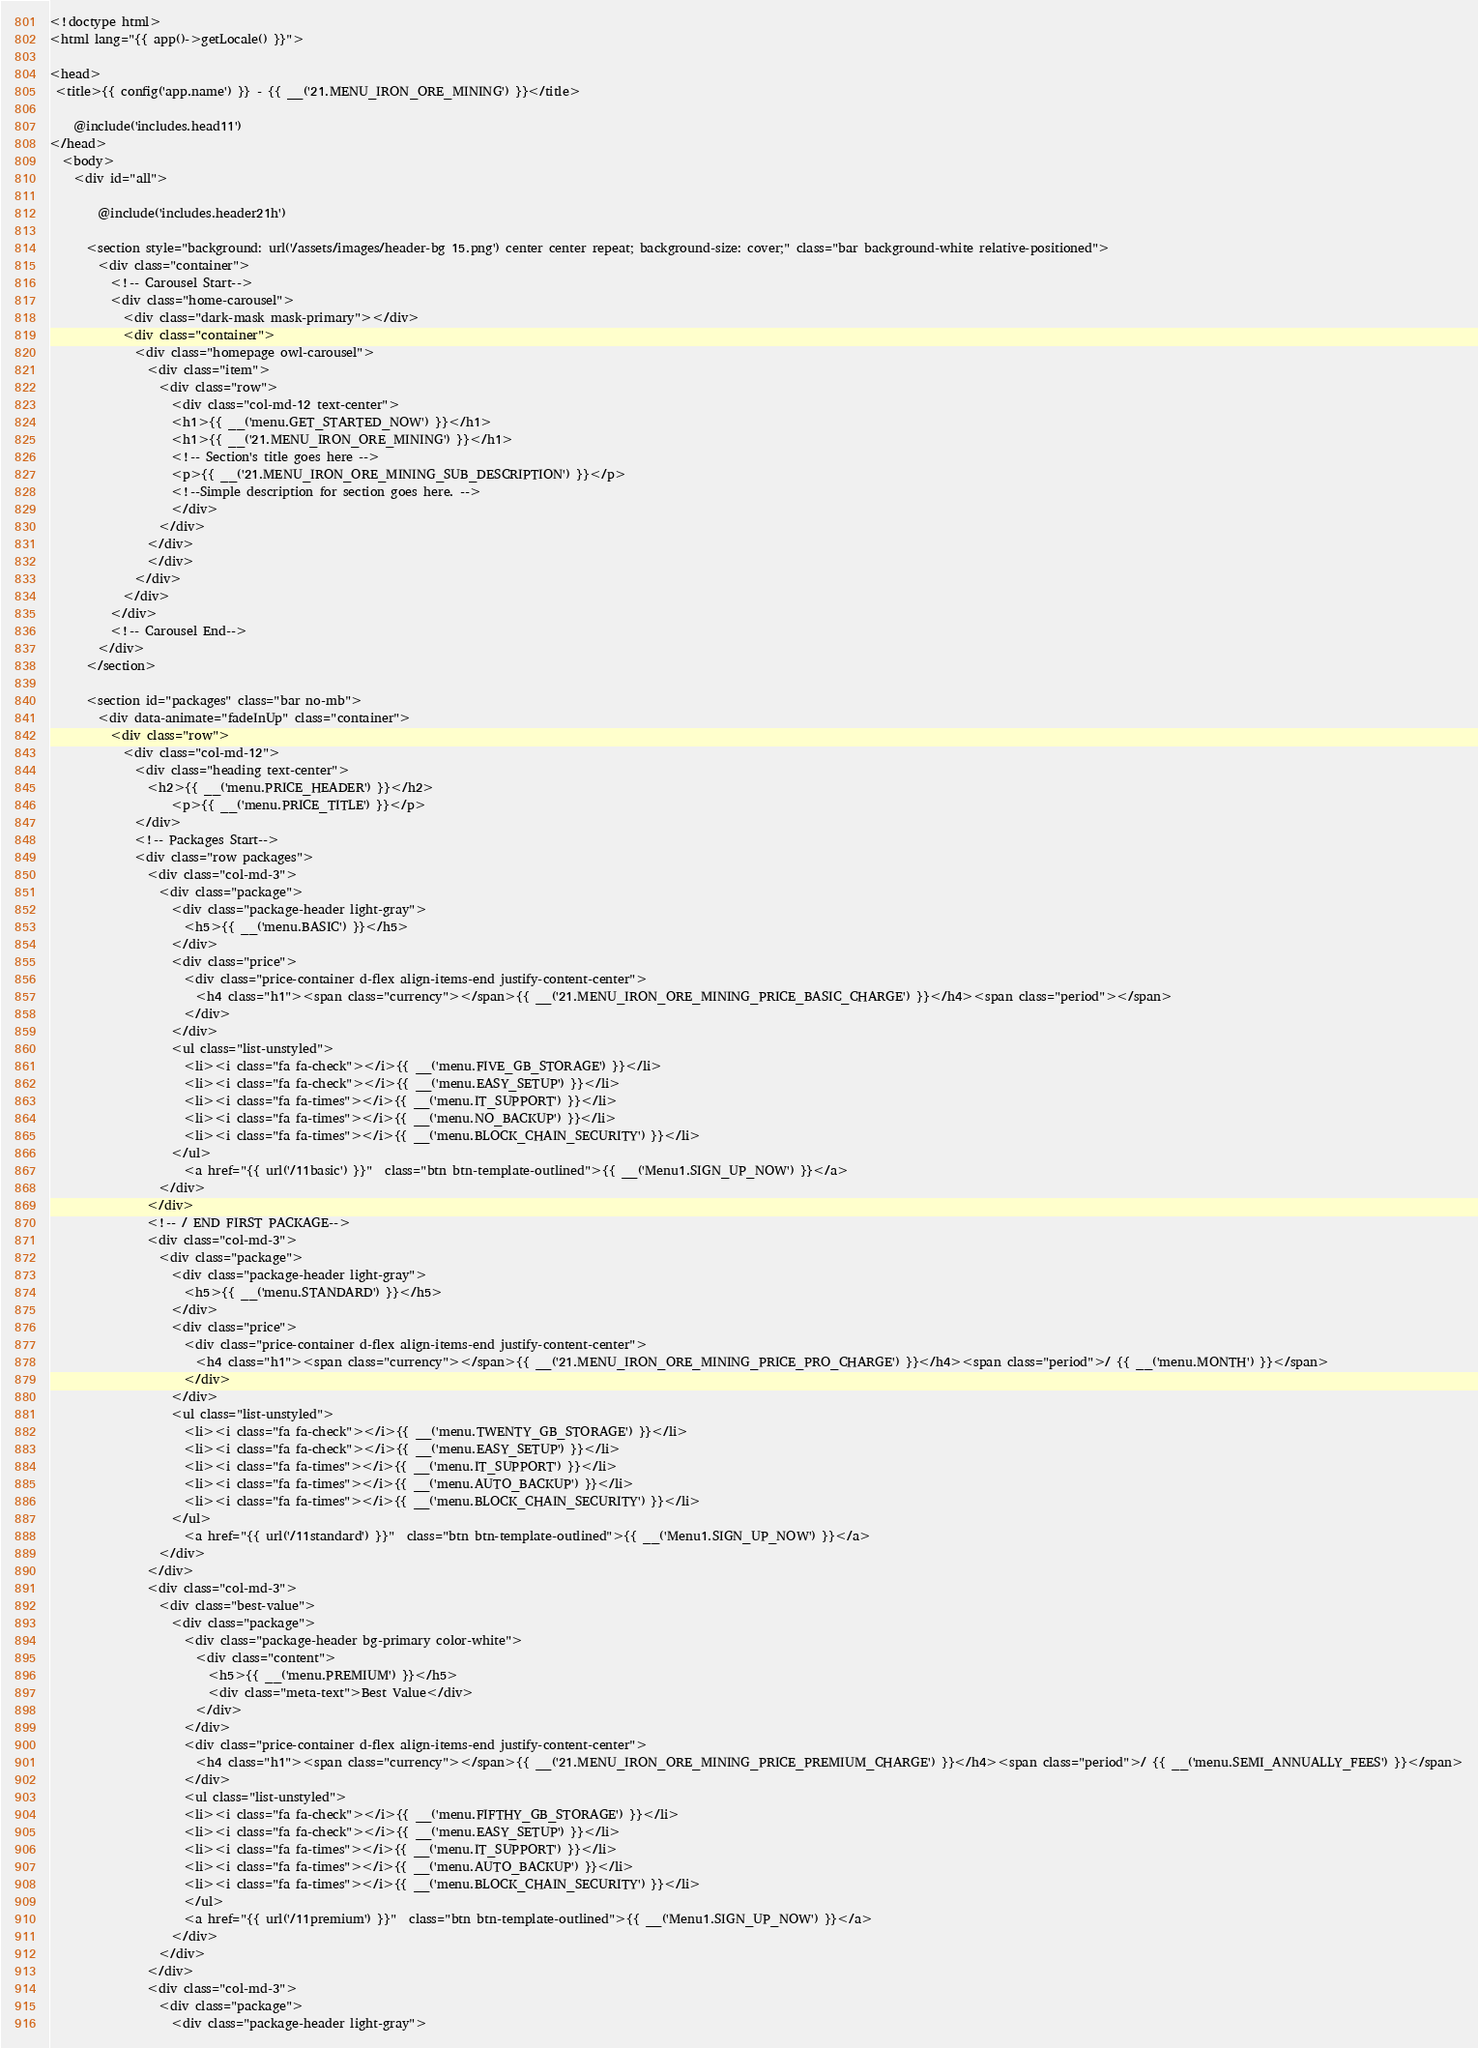Convert code to text. <code><loc_0><loc_0><loc_500><loc_500><_PHP_><!doctype html>
<html lang="{{ app()->getLocale() }}">
	  
<head>  
 <title>{{ config('app.name') }} - {{ __('21.MENU_IRON_ORE_MINING') }}</title>    
	
    @include('includes.head11')
</head>   
  <body>
    <div id="all">  
		
        @include('includes.header21h') 
      
      <section style="background: url('/assets/images/header-bg 15.png') center center repeat; background-size: cover;" class="bar background-white relative-positioned">
        <div class="container">
          <!-- Carousel Start-->
          <div class="home-carousel">
            <div class="dark-mask mask-primary"></div>
            <div class="container">
              <div class="homepage owl-carousel">
                <div class="item">
                  <div class="row">
                    <div class="col-md-12 text-center"> 
					<h1>{{ __('menu.GET_STARTED_NOW') }}</h1>
					<h1>{{ __('21.MENU_IRON_ORE_MINING') }}</h1>
					<!-- Section's title goes here -->
					<p>{{ __('21.MENU_IRON_ORE_MINING_SUB_DESCRIPTION') }}</p>
					<!--Simple description for section goes here. -->
                    </div> 
                  </div>
                </div>  
                </div>
              </div>
            </div>
          </div>
          <!-- Carousel End--> 
        </div>
      </section>
		
      <section id="packages" class="bar no-mb">
        <div data-animate="fadeInUp" class="container">
          <div class="row">
            <div class="col-md-12">
              <div class="heading text-center">
                <h2>{{ __('menu.PRICE_HEADER') }}</h2>
					<p>{{ __('menu.PRICE_TITLE') }}</p>
              </div> 
              <!-- Packages Start-->
              <div class="row packages">
                <div class="col-md-3">
                  <div class="package">
                    <div class="package-header light-gray">
                      <h5>{{ __('menu.BASIC') }}</h5>
                    </div>
                    <div class="price">
                      <div class="price-container d-flex align-items-end justify-content-center">
                        <h4 class="h1"><span class="currency"></span>{{ __('21.MENU_IRON_ORE_MINING_PRICE_BASIC_CHARGE') }}</h4><span class="period"></span>
                      </div>
                    </div>
                    <ul class="list-unstyled">
                      <li><i class="fa fa-check"></i>{{ __('menu.FIVE_GB_STORAGE') }}</li>
                      <li><i class="fa fa-check"></i>{{ __('menu.EASY_SETUP') }}</li>
                      <li><i class="fa fa-times"></i>{{ __('menu.IT_SUPPORT') }}</li>
                      <li><i class="fa fa-times"></i>{{ __('menu.NO_BACKUP') }}</li>
                      <li><i class="fa fa-times"></i>{{ __('menu.BLOCK_CHAIN_SECURITY') }}</li>
                    </ul>
					  <a href="{{ url('/11basic') }}"  class="btn btn-template-outlined">{{ __('Menu1.SIGN_UP_NOW') }}</a> 
                  </div>
                </div>
                <!-- / END FIRST PACKAGE-->
                <div class="col-md-3">
                  <div class="package">
                    <div class="package-header light-gray">
                      <h5>{{ __('menu.STANDARD') }}</h5>
                    </div>
                    <div class="price">
                      <div class="price-container d-flex align-items-end justify-content-center">
                        <h4 class="h1"><span class="currency"></span>{{ __('21.MENU_IRON_ORE_MINING_PRICE_PRO_CHARGE') }}</h4><span class="period">/ {{ __('menu.MONTH') }}</span>
                      </div>
                    </div>
                    <ul class="list-unstyled">
                      <li><i class="fa fa-check"></i>{{ __('menu.TWENTY_GB_STORAGE') }}</li>
                      <li><i class="fa fa-check"></i>{{ __('menu.EASY_SETUP') }}</li>
                      <li><i class="fa fa-times"></i>{{ __('menu.IT_SUPPORT') }}</li>
                      <li><i class="fa fa-times"></i>{{ __('menu.AUTO_BACKUP') }}</li>
                      <li><i class="fa fa-times"></i>{{ __('menu.BLOCK_CHAIN_SECURITY') }}</li>
                    </ul>
					  <a href="{{ url('/11standard') }}"  class="btn btn-template-outlined">{{ __('Menu1.SIGN_UP_NOW') }}</a>
                  </div>
                </div>
                <div class="col-md-3">
                  <div class="best-value">
                    <div class="package">
                      <div class="package-header bg-primary color-white">
                        <div class="content">
                          <h5>{{ __('menu.PREMIUM') }}</h5>
                          <div class="meta-text">Best Value</div>
                        </div>
                      </div>
                      <div class="price-container d-flex align-items-end justify-content-center">
                        <h4 class="h1"><span class="currency"></span>{{ __('21.MENU_IRON_ORE_MINING_PRICE_PREMIUM_CHARGE') }}</h4><span class="period">/ {{ __('menu.SEMI_ANNUALLY_FEES') }}</span>
                      </div>
                      <ul class="list-unstyled">
                      <li><i class="fa fa-check"></i>{{ __('menu.FIFTHY_GB_STORAGE') }}</li>
                      <li><i class="fa fa-check"></i>{{ __('menu.EASY_SETUP') }}</li>
                      <li><i class="fa fa-times"></i>{{ __('menu.IT_SUPPORT') }}</li>
                      <li><i class="fa fa-times"></i>{{ __('menu.AUTO_BACKUP') }}</li>
                      <li><i class="fa fa-times"></i>{{ __('menu.BLOCK_CHAIN_SECURITY') }}</li>
                      </ul>
					  <a href="{{ url('/11premium') }}"  class="btn btn-template-outlined">{{ __('Menu1.SIGN_UP_NOW') }}</a>
                    </div>
                  </div>
                </div>
                <div class="col-md-3">
                  <div class="package">
                    <div class="package-header light-gray"></code> 